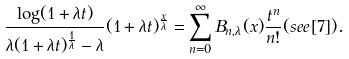Convert formula to latex. <formula><loc_0><loc_0><loc_500><loc_500>\frac { \log ( 1 + \lambda t ) } { \lambda ( 1 + \lambda t ) ^ { \frac { 1 } { \lambda } } - \lambda } ( 1 + \lambda t ) ^ { \frac { x } { \lambda } } = \sum _ { n = 0 } ^ { \infty } B _ { n , \lambda } ( x ) \frac { t ^ { n } } { n ! } ( s e e \, [ 7 ] ) .</formula> 